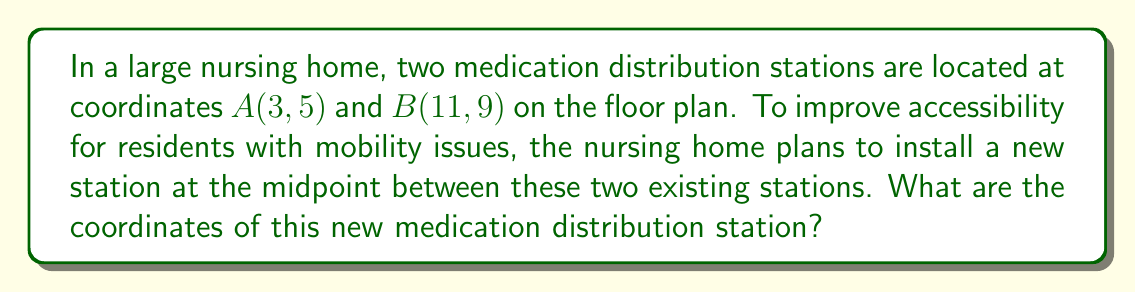Can you answer this question? To find the midpoint between two points, we use the midpoint formula:

$$ \text{Midpoint} = \left(\frac{x_1 + x_2}{2}, \frac{y_1 + y_2}{2}\right) $$

Where $(x_1, y_1)$ are the coordinates of the first point and $(x_2, y_2)$ are the coordinates of the second point.

Given:
- Point $A(3, 5)$, so $x_1 = 3$ and $y_1 = 5$
- Point $B(11, 9)$, so $x_2 = 11$ and $y_2 = 9$

Step 1: Calculate the x-coordinate of the midpoint
$$ x = \frac{x_1 + x_2}{2} = \frac{3 + 11}{2} = \frac{14}{2} = 7 $$

Step 2: Calculate the y-coordinate of the midpoint
$$ y = \frac{y_1 + y_2}{2} = \frac{5 + 9}{2} = \frac{14}{2} = 7 $$

Therefore, the coordinates of the new medication distribution station are $(7, 7)$.
Answer: $(7, 7)$ 